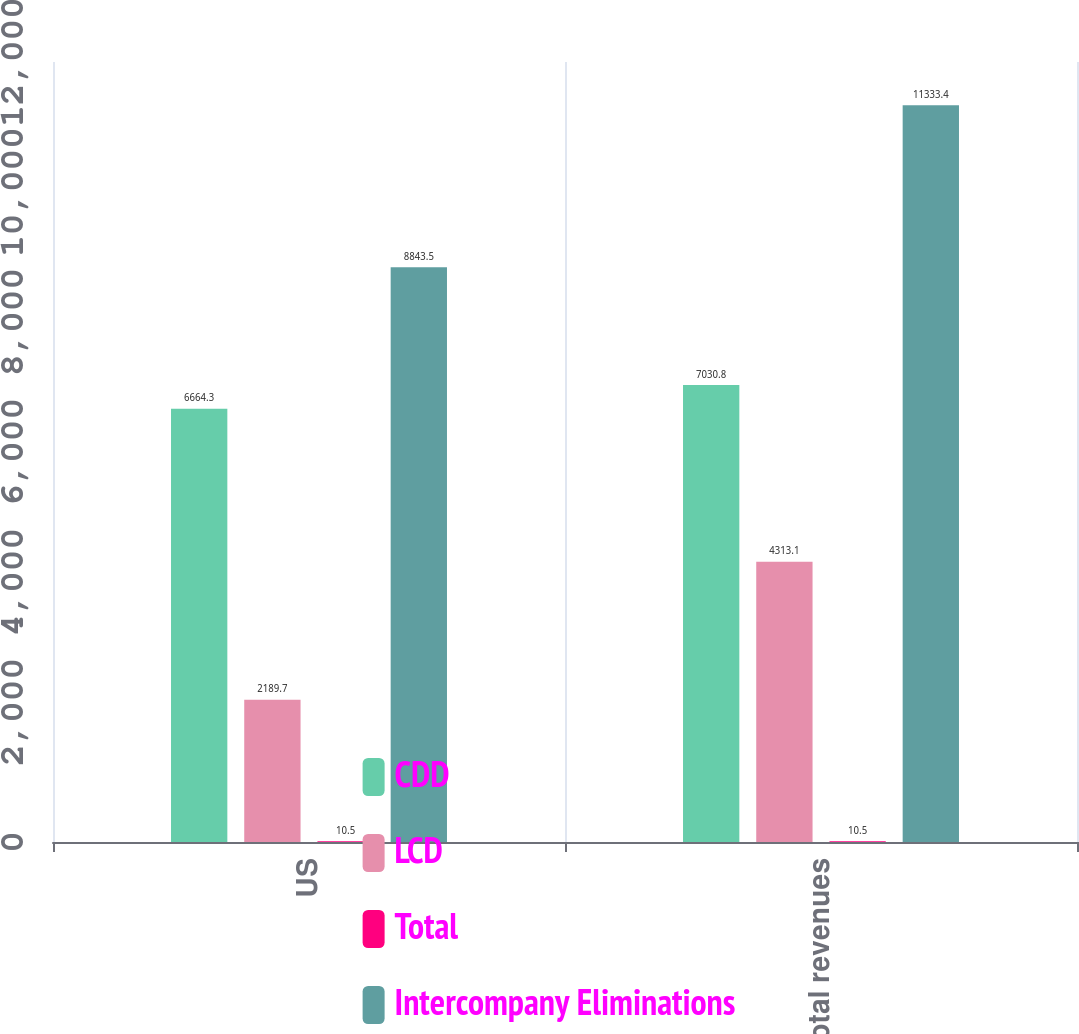<chart> <loc_0><loc_0><loc_500><loc_500><stacked_bar_chart><ecel><fcel>US<fcel>Total revenues<nl><fcel>CDD<fcel>6664.3<fcel>7030.8<nl><fcel>LCD<fcel>2189.7<fcel>4313.1<nl><fcel>Total<fcel>10.5<fcel>10.5<nl><fcel>Intercompany Eliminations<fcel>8843.5<fcel>11333.4<nl></chart> 